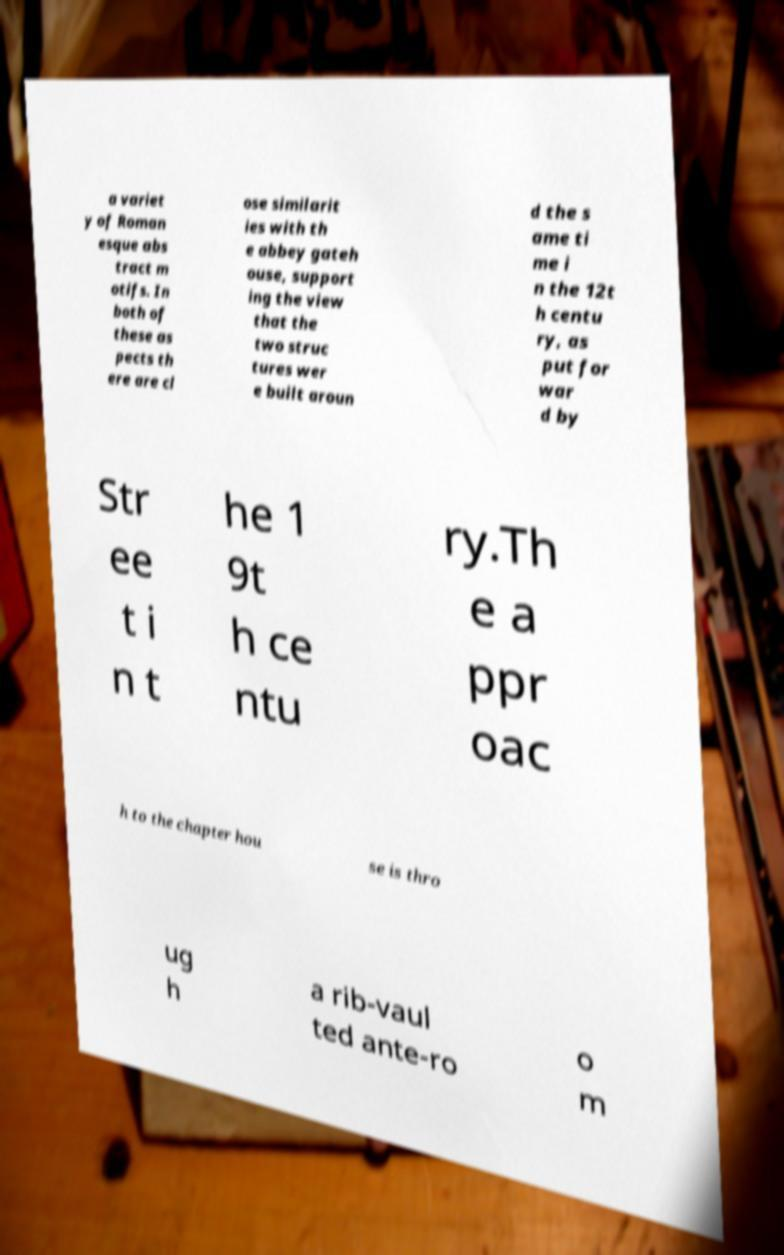Can you read and provide the text displayed in the image?This photo seems to have some interesting text. Can you extract and type it out for me? a variet y of Roman esque abs tract m otifs. In both of these as pects th ere are cl ose similarit ies with th e abbey gateh ouse, support ing the view that the two struc tures wer e built aroun d the s ame ti me i n the 12t h centu ry, as put for war d by Str ee t i n t he 1 9t h ce ntu ry.Th e a ppr oac h to the chapter hou se is thro ug h a rib-vaul ted ante-ro o m 